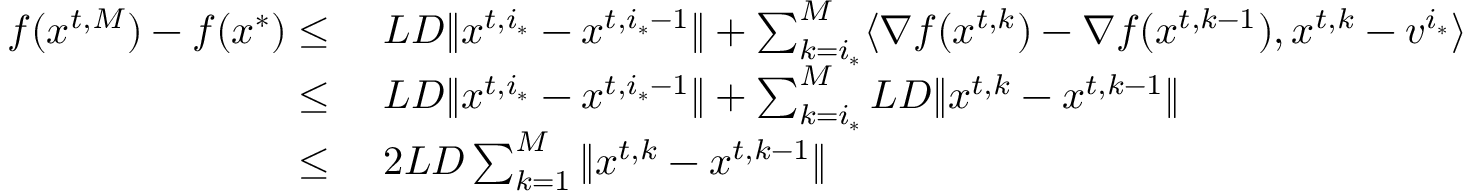Convert formula to latex. <formula><loc_0><loc_0><loc_500><loc_500>\begin{array} { r l } { f ( { x } ^ { t , M } ) - f ( { x } ^ { * } ) \leq \ } & { L D \| { x } ^ { t , i _ { * } } - { x } ^ { t , i _ { * } - 1 } \| + \sum _ { k = i _ { * } } ^ { M } \langle \nabla f ( { x } ^ { t , k } ) - \nabla f ( { x } ^ { t , k - 1 } ) , { x } ^ { t , k } - { v } ^ { i _ { * } } \rangle } \\ { \leq \ } & { L D \| { x } ^ { t , i _ { * } } - { x } ^ { t , i _ { * } - 1 } \| + \sum _ { k = i _ { * } } ^ { M } L D \| { x } ^ { t , k } - { x } ^ { t , k - 1 } \| } \\ { \leq \ } & { 2 L D \sum _ { k = 1 } ^ { M } \| { x } ^ { t , k } - { x } ^ { t , k - 1 } \| } \end{array}</formula> 